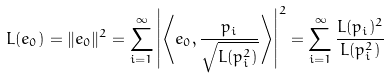<formula> <loc_0><loc_0><loc_500><loc_500>L ( e _ { 0 } ) = \| e _ { 0 } \| ^ { 2 } = \sum _ { i = 1 } ^ { \infty } \left | \left \langle e _ { 0 } , \frac { p _ { i } } { \sqrt { L ( p _ { i } ^ { 2 } ) } } \right \rangle \right | ^ { 2 } = \sum _ { i = 1 } ^ { \infty } \frac { L ( p _ { i } ) ^ { 2 } } { L ( p _ { i } ^ { 2 } ) }</formula> 